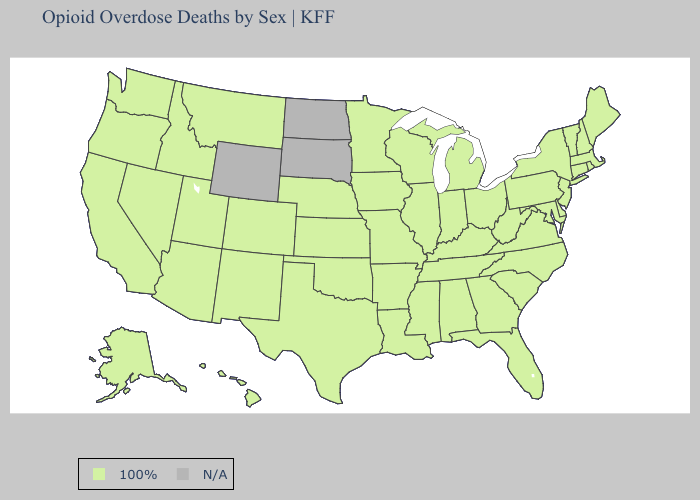What is the value of South Carolina?
Concise answer only. 100%. Does the first symbol in the legend represent the smallest category?
Concise answer only. Yes. What is the value of South Carolina?
Short answer required. 100%. Name the states that have a value in the range N/A?
Short answer required. North Dakota, South Dakota, Wyoming. What is the lowest value in the West?
Short answer required. 100%. What is the value of Maryland?
Be succinct. 100%. Which states have the lowest value in the USA?
Quick response, please. Alabama, Alaska, Arizona, Arkansas, California, Colorado, Connecticut, Delaware, Florida, Georgia, Hawaii, Idaho, Illinois, Indiana, Iowa, Kansas, Kentucky, Louisiana, Maine, Maryland, Massachusetts, Michigan, Minnesota, Mississippi, Missouri, Montana, Nebraska, Nevada, New Hampshire, New Jersey, New Mexico, New York, North Carolina, Ohio, Oklahoma, Oregon, Pennsylvania, Rhode Island, South Carolina, Tennessee, Texas, Utah, Vermont, Virginia, Washington, West Virginia, Wisconsin. 